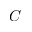<formula> <loc_0><loc_0><loc_500><loc_500>C</formula> 